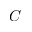<formula> <loc_0><loc_0><loc_500><loc_500>C</formula> 